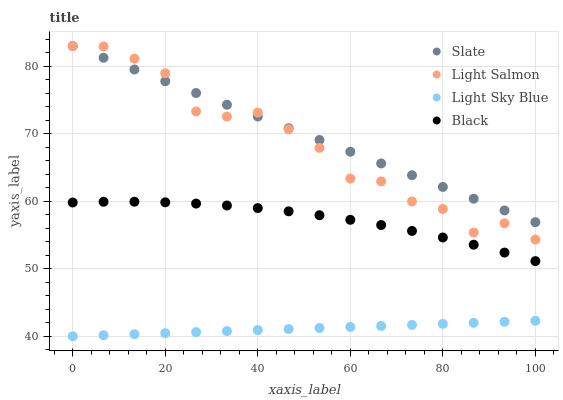Does Light Sky Blue have the minimum area under the curve?
Answer yes or no. Yes. Does Slate have the maximum area under the curve?
Answer yes or no. Yes. Does Black have the minimum area under the curve?
Answer yes or no. No. Does Black have the maximum area under the curve?
Answer yes or no. No. Is Light Sky Blue the smoothest?
Answer yes or no. Yes. Is Light Salmon the roughest?
Answer yes or no. Yes. Is Black the smoothest?
Answer yes or no. No. Is Black the roughest?
Answer yes or no. No. Does Light Sky Blue have the lowest value?
Answer yes or no. Yes. Does Black have the lowest value?
Answer yes or no. No. Does Light Salmon have the highest value?
Answer yes or no. Yes. Does Black have the highest value?
Answer yes or no. No. Is Light Sky Blue less than Slate?
Answer yes or no. Yes. Is Light Salmon greater than Light Sky Blue?
Answer yes or no. Yes. Does Slate intersect Light Salmon?
Answer yes or no. Yes. Is Slate less than Light Salmon?
Answer yes or no. No. Is Slate greater than Light Salmon?
Answer yes or no. No. Does Light Sky Blue intersect Slate?
Answer yes or no. No. 